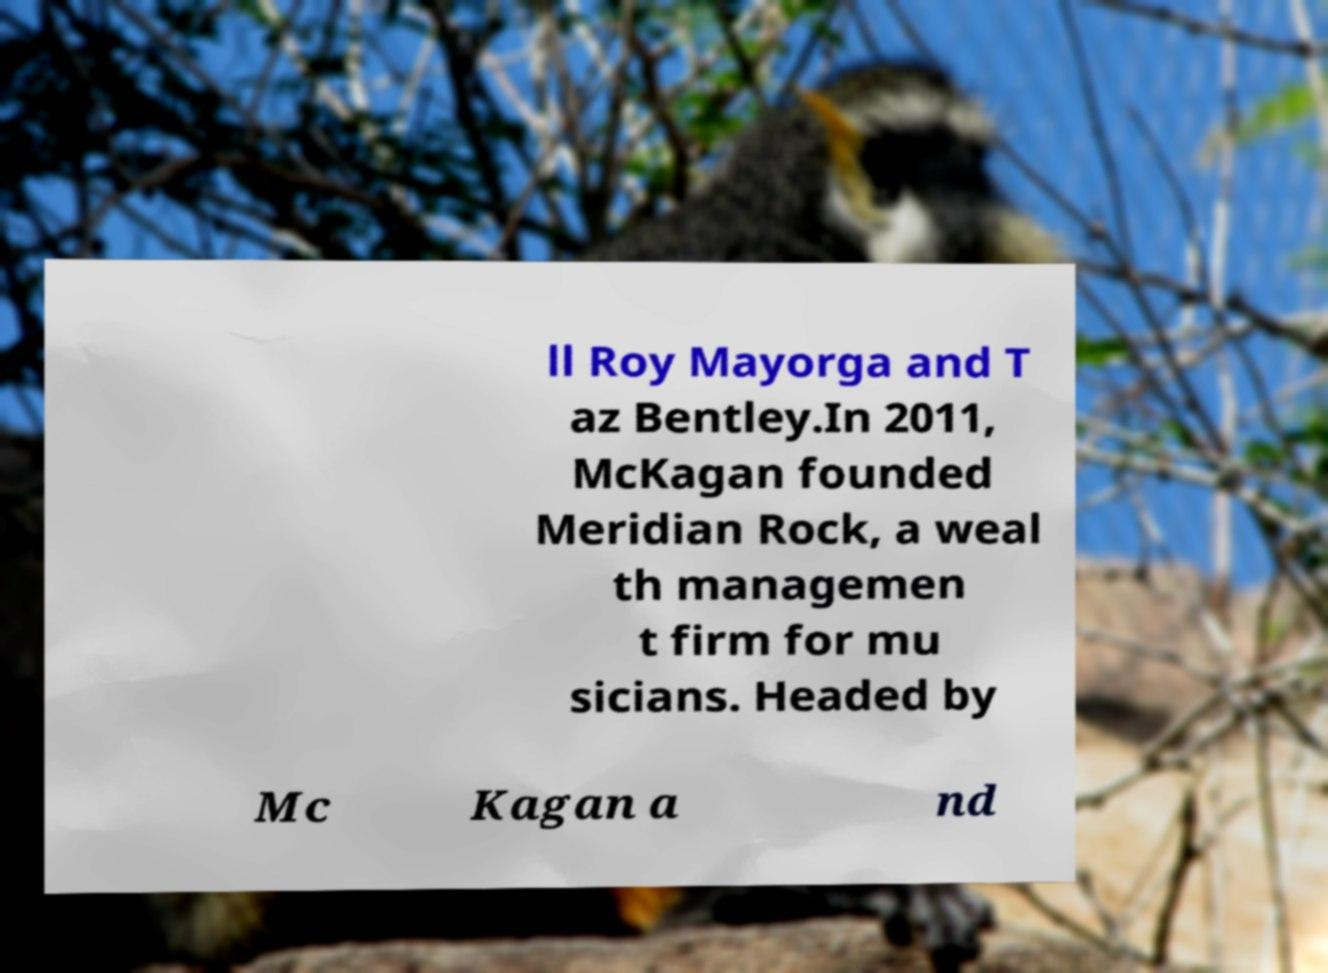What messages or text are displayed in this image? I need them in a readable, typed format. ll Roy Mayorga and T az Bentley.In 2011, McKagan founded Meridian Rock, a weal th managemen t firm for mu sicians. Headed by Mc Kagan a nd 